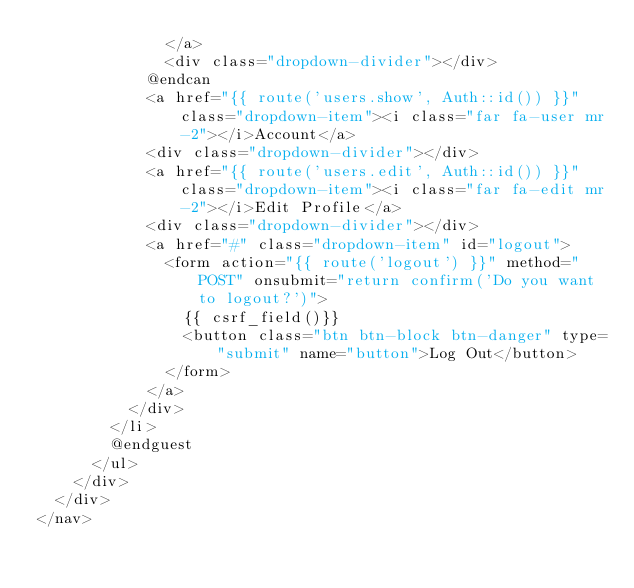Convert code to text. <code><loc_0><loc_0><loc_500><loc_500><_PHP_>              </a>
              <div class="dropdown-divider"></div>
            @endcan
            <a href="{{ route('users.show', Auth::id()) }}" class="dropdown-item"><i class="far fa-user mr-2"></i>Account</a>
            <div class="dropdown-divider"></div>
            <a href="{{ route('users.edit', Auth::id()) }}" class="dropdown-item"><i class="far fa-edit mr-2"></i>Edit Profile</a>
            <div class="dropdown-divider"></div>
            <a href="#" class="dropdown-item" id="logout">
              <form action="{{ route('logout') }}" method="POST" onsubmit="return confirm('Do you want to logout?')">
                {{ csrf_field()}}
                <button class="btn btn-block btn-danger" type="submit" name="button">Log Out</button>
              </form>
            </a>
          </div>
        </li>
        @endguest
      </ul>
    </div>
  </div>
</nav>
</code> 